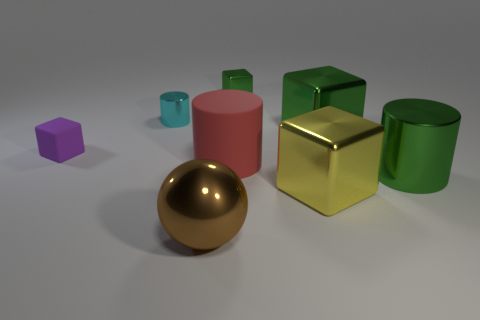Can you describe the lighting in the scene? The lighting in the scene is diffuse, coming from no visible direct source. It casts soft shadows on the ground from each object, suggesting an ambient light setup often used in studio renderings. Does the lighting affect the colors of the objects? Yes, the diffuse lighting helps maintain the true colors of the objects without creating strong highlights or deep shadows, allowing for the inherent colors and material finishes to be clearly visible. 